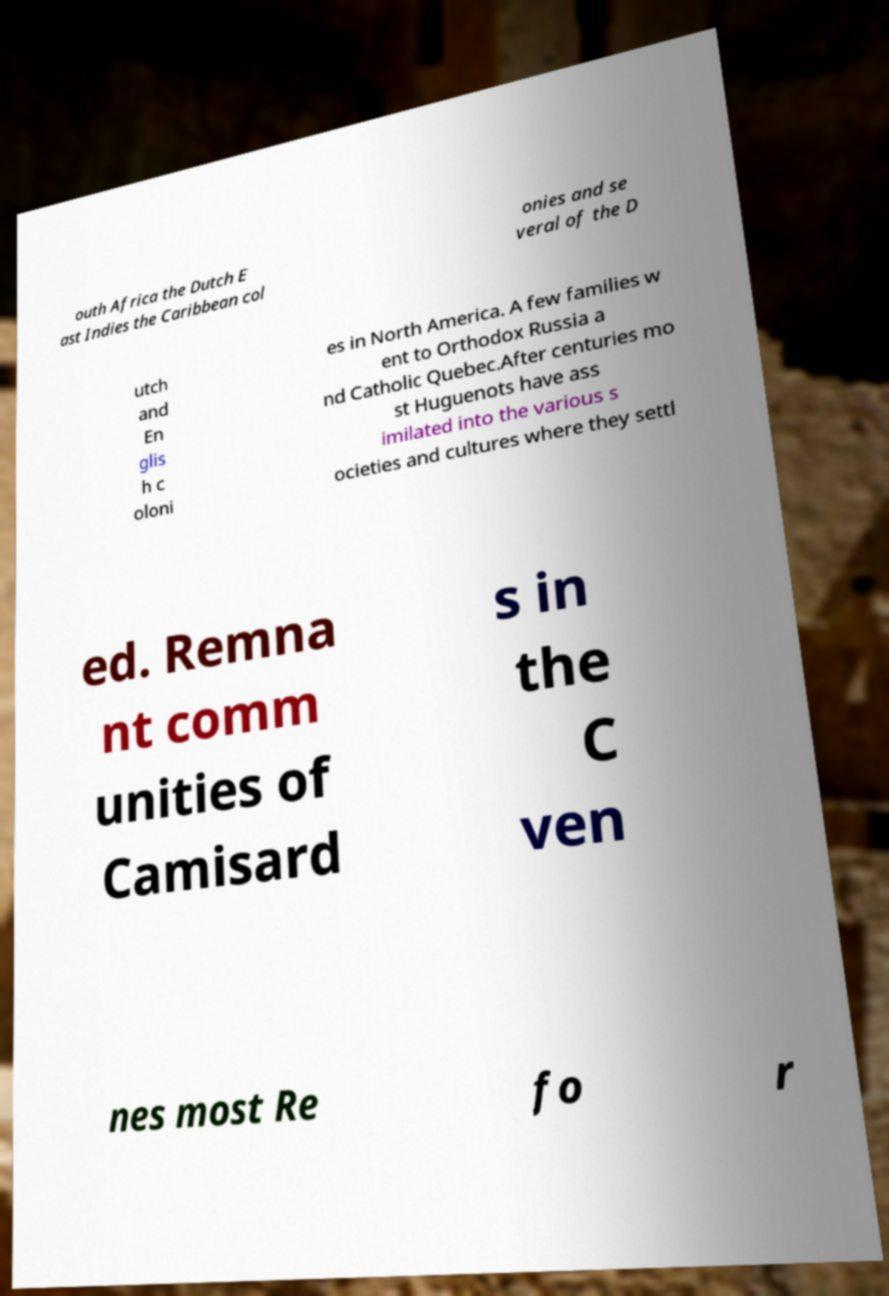For documentation purposes, I need the text within this image transcribed. Could you provide that? outh Africa the Dutch E ast Indies the Caribbean col onies and se veral of the D utch and En glis h c oloni es in North America. A few families w ent to Orthodox Russia a nd Catholic Quebec.After centuries mo st Huguenots have ass imilated into the various s ocieties and cultures where they settl ed. Remna nt comm unities of Camisard s in the C ven nes most Re fo r 